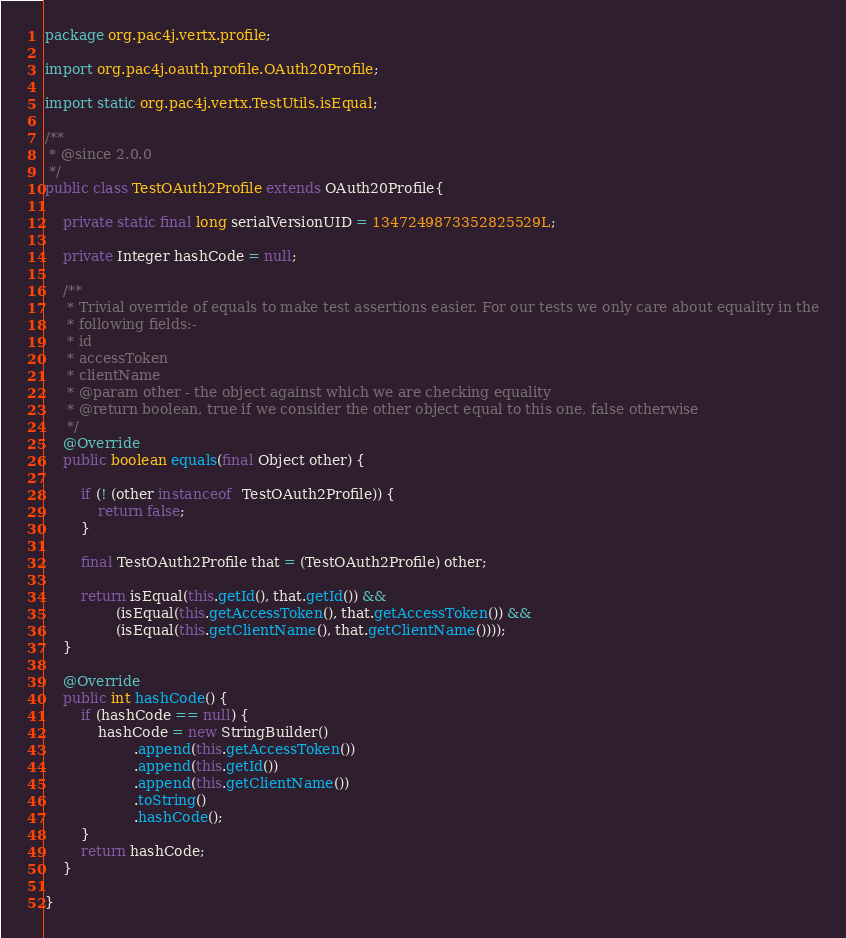<code> <loc_0><loc_0><loc_500><loc_500><_Java_>package org.pac4j.vertx.profile;

import org.pac4j.oauth.profile.OAuth20Profile;

import static org.pac4j.vertx.TestUtils.isEqual;

/**
 * @since 2.0.0
 */
public class TestOAuth2Profile extends OAuth20Profile{

    private static final long serialVersionUID = 1347249873352825529L;

    private Integer hashCode = null;

    /**
     * Trivial override of equals to make test assertions easier. For our tests we only care about equality in the
     * following fields:-
     * id
     * accessToken
     * clientName
     * @param other - the object against which we are checking equality
     * @return boolean, true if we consider the other object equal to this one, false otherwise
     */
    @Override
    public boolean equals(final Object other) {

        if (! (other instanceof  TestOAuth2Profile)) {
            return false;
        }

        final TestOAuth2Profile that = (TestOAuth2Profile) other;

        return isEqual(this.getId(), that.getId()) &&
                (isEqual(this.getAccessToken(), that.getAccessToken()) &&
                (isEqual(this.getClientName(), that.getClientName())));
    }

    @Override
    public int hashCode() {
        if (hashCode == null) {
            hashCode = new StringBuilder()
                    .append(this.getAccessToken())
                    .append(this.getId())
                    .append(this.getClientName())
                    .toString()
                    .hashCode();
        }
        return hashCode;
    }

}
</code> 